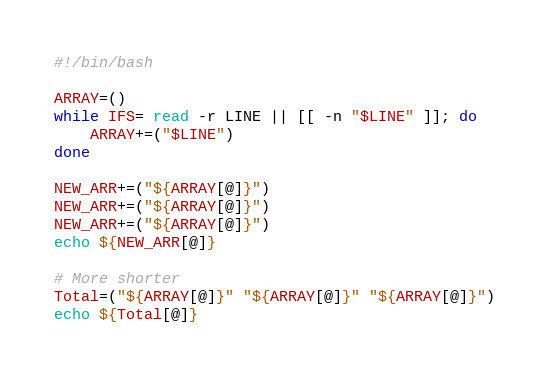<code> <loc_0><loc_0><loc_500><loc_500><_Bash_>#!/bin/bash

ARRAY=()
while IFS= read -r LINE || [[ -n "$LINE" ]]; do
    ARRAY+=("$LINE")
done

NEW_ARR+=("${ARRAY[@]}")
NEW_ARR+=("${ARRAY[@]}")
NEW_ARR+=("${ARRAY[@]}")
echo ${NEW_ARR[@]}

# More shorter
Total=("${ARRAY[@]}" "${ARRAY[@]}" "${ARRAY[@]}")
echo ${Total[@]}

</code> 